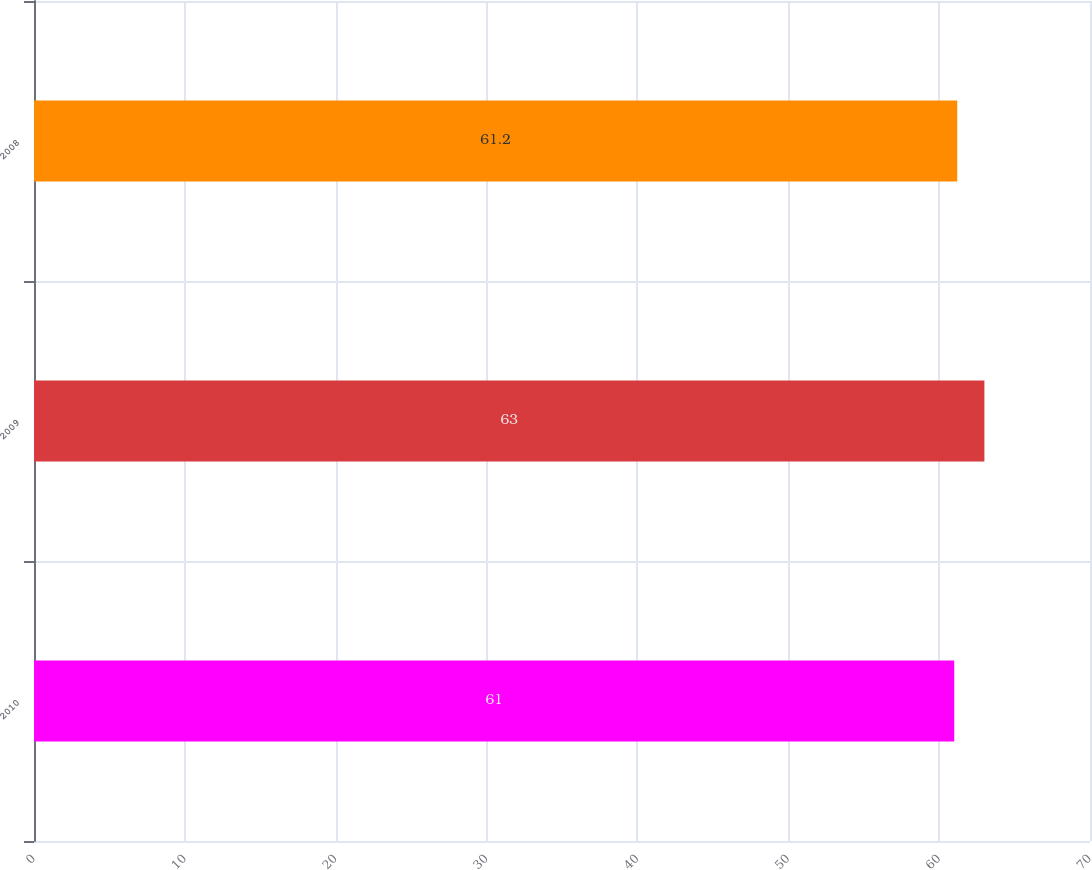Convert chart. <chart><loc_0><loc_0><loc_500><loc_500><bar_chart><fcel>2010<fcel>2009<fcel>2008<nl><fcel>61<fcel>63<fcel>61.2<nl></chart> 